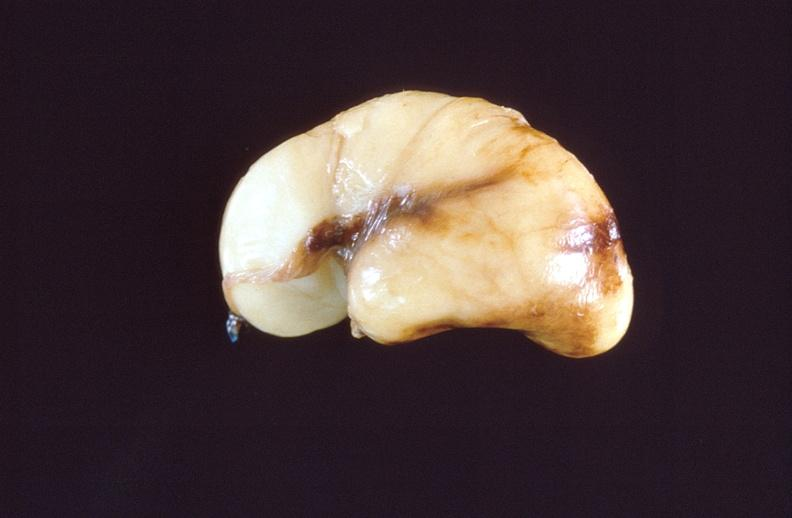s nervous present?
Answer the question using a single word or phrase. Yes 